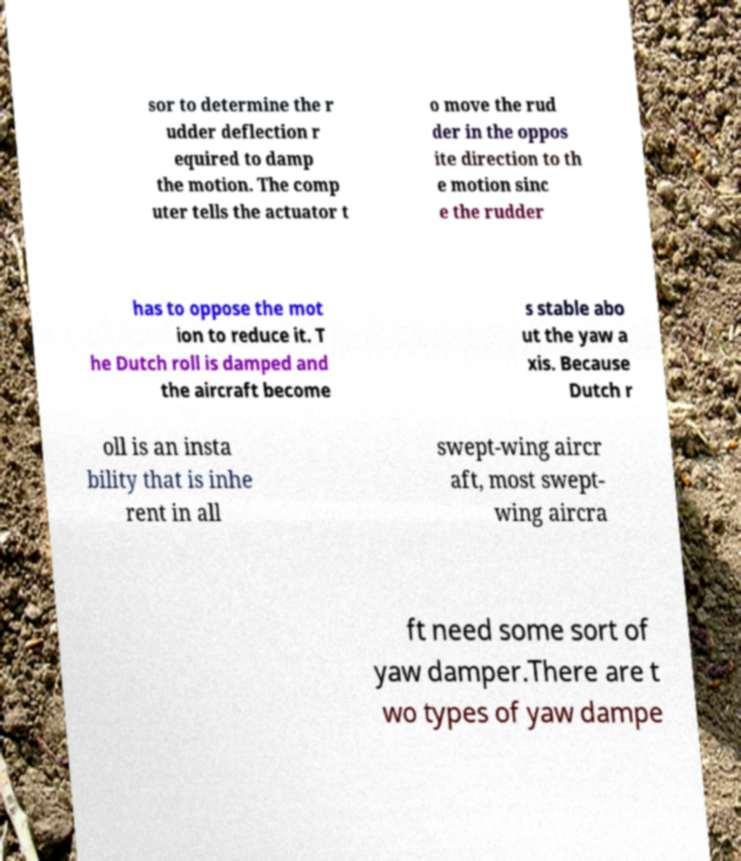I need the written content from this picture converted into text. Can you do that? sor to determine the r udder deflection r equired to damp the motion. The comp uter tells the actuator t o move the rud der in the oppos ite direction to th e motion sinc e the rudder has to oppose the mot ion to reduce it. T he Dutch roll is damped and the aircraft become s stable abo ut the yaw a xis. Because Dutch r oll is an insta bility that is inhe rent in all swept-wing aircr aft, most swept- wing aircra ft need some sort of yaw damper.There are t wo types of yaw dampe 